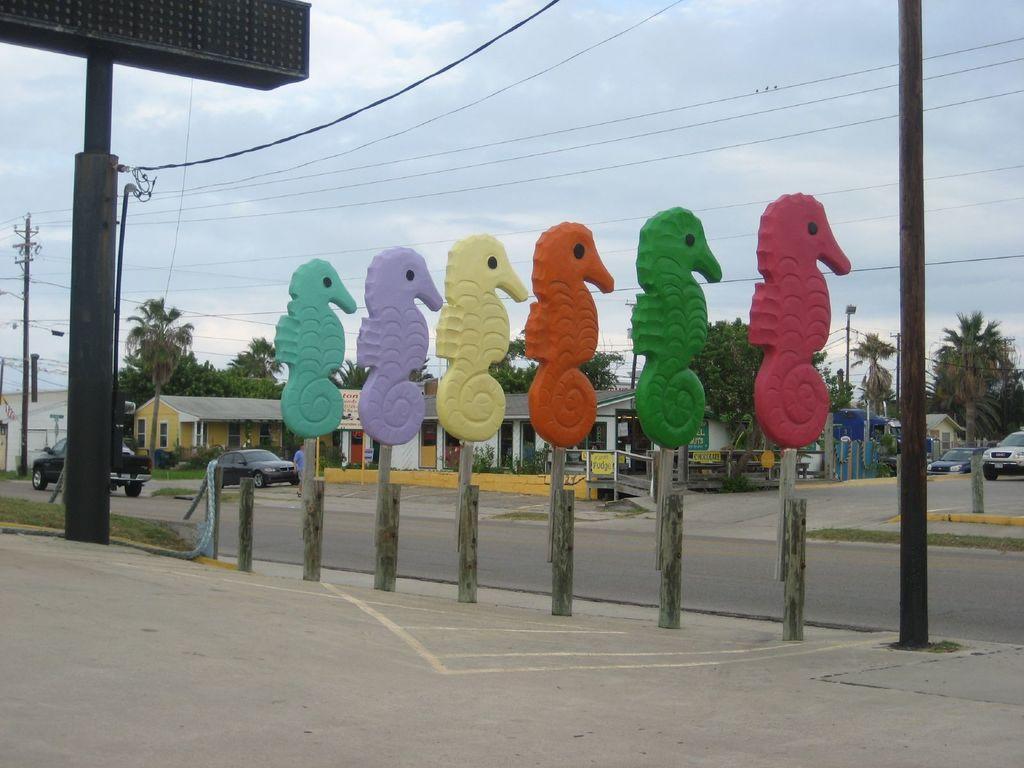Please provide a concise description of this image. This picture shows about the colorful horse statues placed on the footpath. Beside there is black color board with some poles and cables. In the background we can see small shed houses and some trees. 